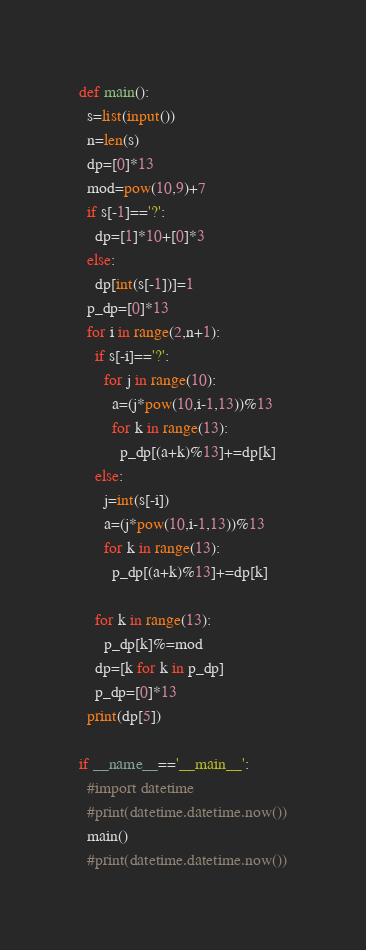Convert code to text. <code><loc_0><loc_0><loc_500><loc_500><_Python_>def main():
  s=list(input())
  n=len(s)
  dp=[0]*13
  mod=pow(10,9)+7
  if s[-1]=='?':
    dp=[1]*10+[0]*3
  else:
    dp[int(s[-1])]=1
  p_dp=[0]*13
  for i in range(2,n+1):
    if s[-i]=='?':
      for j in range(10):
        a=(j*pow(10,i-1,13))%13
        for k in range(13):
          p_dp[(a+k)%13]+=dp[k]
    else:
      j=int(s[-i])
      a=(j*pow(10,i-1,13))%13
      for k in range(13):
        p_dp[(a+k)%13]+=dp[k]
    
    for k in range(13):
      p_dp[k]%=mod
    dp=[k for k in p_dp]
    p_dp=[0]*13
  print(dp[5])

if __name__=='__main__':
  #import datetime
  #print(datetime.datetime.now())
  main()
  #print(datetime.datetime.now())
</code> 